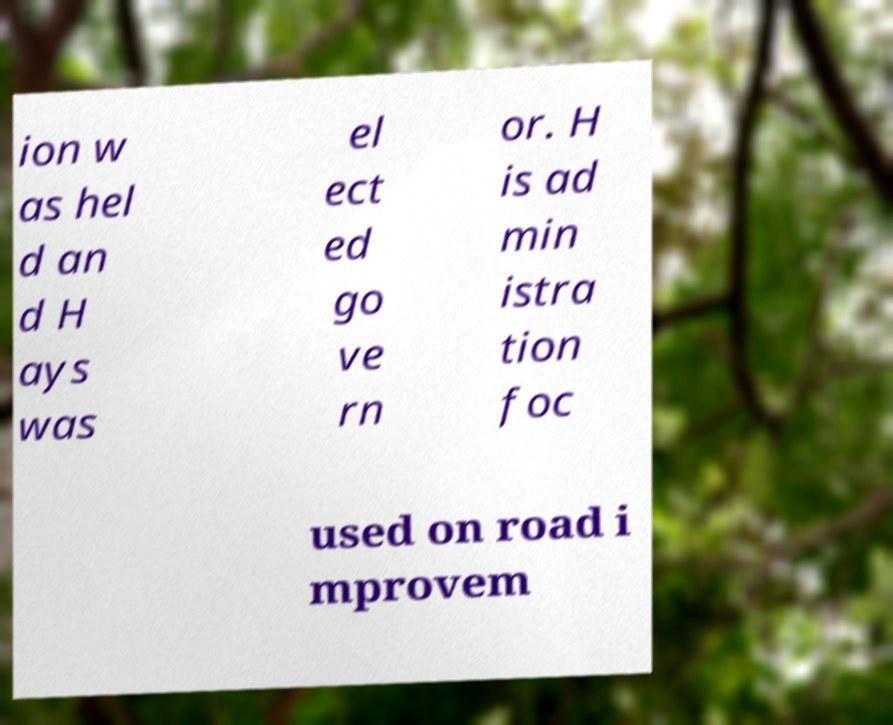I need the written content from this picture converted into text. Can you do that? ion w as hel d an d H ays was el ect ed go ve rn or. H is ad min istra tion foc used on road i mprovem 